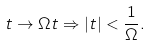Convert formula to latex. <formula><loc_0><loc_0><loc_500><loc_500>t \rightarrow \Omega t \Rightarrow | t | < \frac { 1 } { \Omega } .</formula> 